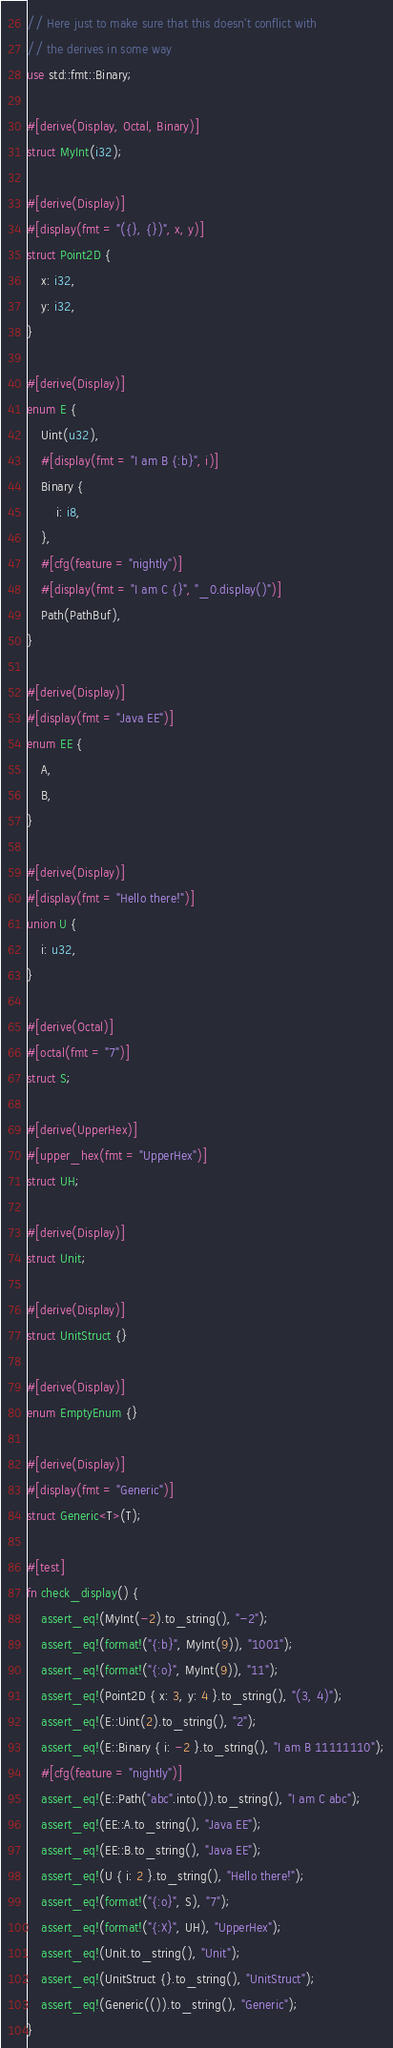Convert code to text. <code><loc_0><loc_0><loc_500><loc_500><_Rust_>// Here just to make sure that this doesn't conflict with
// the derives in some way
use std::fmt::Binary;

#[derive(Display, Octal, Binary)]
struct MyInt(i32);

#[derive(Display)]
#[display(fmt = "({}, {})", x, y)]
struct Point2D {
    x: i32,
    y: i32,
}

#[derive(Display)]
enum E {
    Uint(u32),
    #[display(fmt = "I am B {:b}", i)]
    Binary {
        i: i8,
    },
    #[cfg(feature = "nightly")]
    #[display(fmt = "I am C {}", "_0.display()")]
    Path(PathBuf),
}

#[derive(Display)]
#[display(fmt = "Java EE")]
enum EE {
    A,
    B,
}

#[derive(Display)]
#[display(fmt = "Hello there!")]
union U {
    i: u32,
}

#[derive(Octal)]
#[octal(fmt = "7")]
struct S;

#[derive(UpperHex)]
#[upper_hex(fmt = "UpperHex")]
struct UH;

#[derive(Display)]
struct Unit;

#[derive(Display)]
struct UnitStruct {}

#[derive(Display)]
enum EmptyEnum {}

#[derive(Display)]
#[display(fmt = "Generic")]
struct Generic<T>(T);

#[test]
fn check_display() {
    assert_eq!(MyInt(-2).to_string(), "-2");
    assert_eq!(format!("{:b}", MyInt(9)), "1001");
    assert_eq!(format!("{:o}", MyInt(9)), "11");
    assert_eq!(Point2D { x: 3, y: 4 }.to_string(), "(3, 4)");
    assert_eq!(E::Uint(2).to_string(), "2");
    assert_eq!(E::Binary { i: -2 }.to_string(), "I am B 11111110");
    #[cfg(feature = "nightly")]
    assert_eq!(E::Path("abc".into()).to_string(), "I am C abc");
    assert_eq!(EE::A.to_string(), "Java EE");
    assert_eq!(EE::B.to_string(), "Java EE");
    assert_eq!(U { i: 2 }.to_string(), "Hello there!");
    assert_eq!(format!("{:o}", S), "7");
    assert_eq!(format!("{:X}", UH), "UpperHex");
    assert_eq!(Unit.to_string(), "Unit");
    assert_eq!(UnitStruct {}.to_string(), "UnitStruct");
    assert_eq!(Generic(()).to_string(), "Generic");
}
</code> 